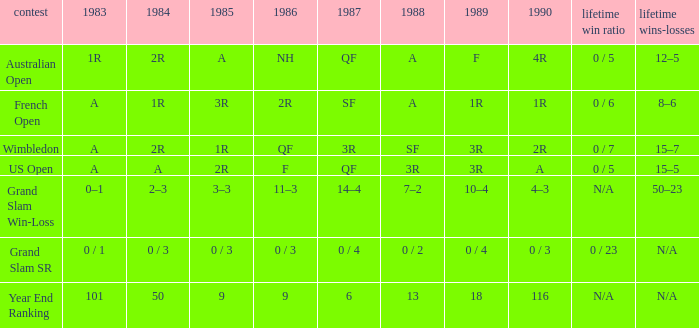What is the result in 1985 when the career win-loss is n/a, and 0 / 23 as the career SR? 0 / 3. 